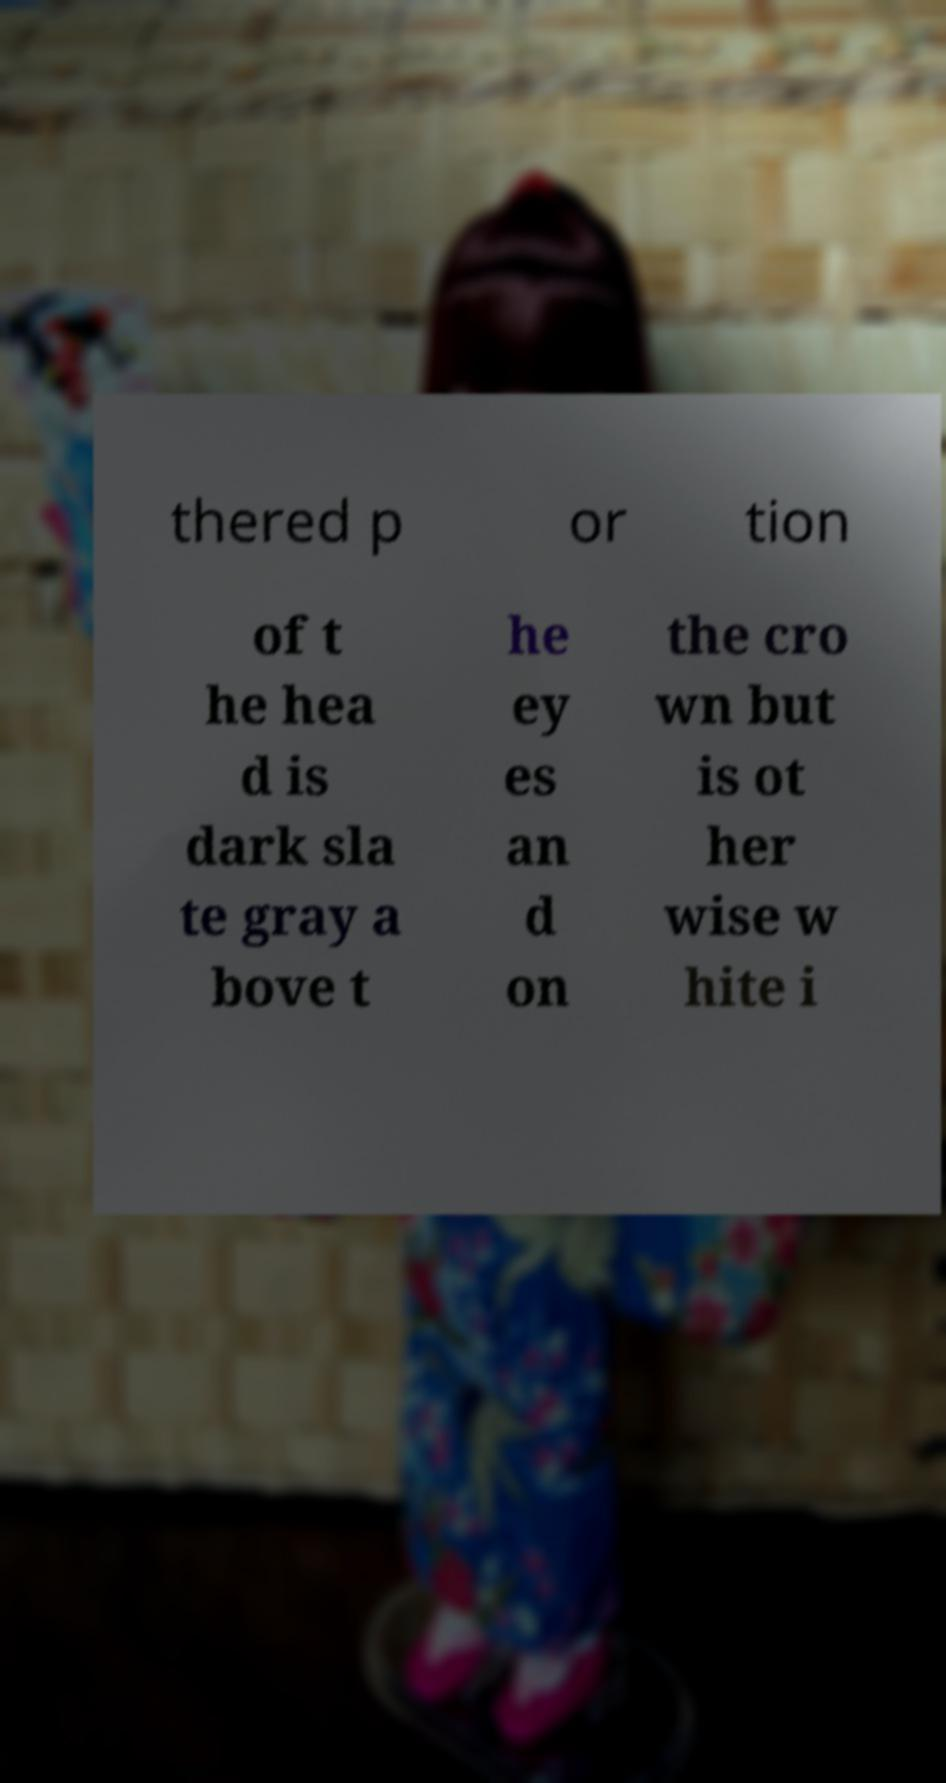Please read and relay the text visible in this image. What does it say? thered p or tion of t he hea d is dark sla te gray a bove t he ey es an d on the cro wn but is ot her wise w hite i 